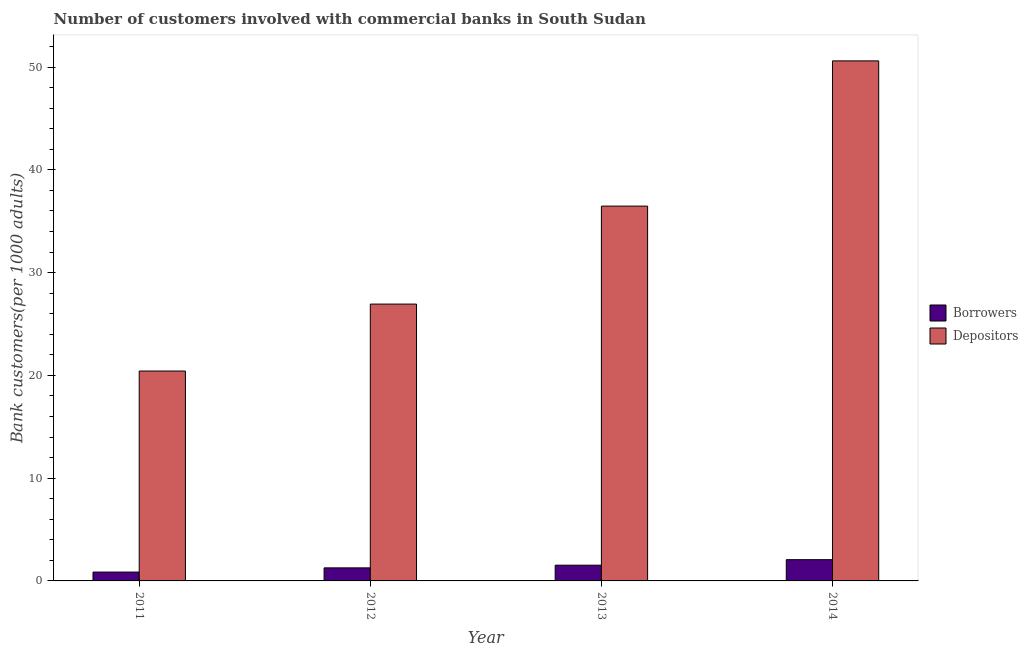How many different coloured bars are there?
Ensure brevity in your answer.  2. Are the number of bars on each tick of the X-axis equal?
Your answer should be very brief. Yes. How many bars are there on the 4th tick from the left?
Keep it short and to the point. 2. How many bars are there on the 2nd tick from the right?
Give a very brief answer. 2. What is the label of the 4th group of bars from the left?
Make the answer very short. 2014. What is the number of borrowers in 2011?
Your answer should be compact. 0.86. Across all years, what is the maximum number of depositors?
Offer a terse response. 50.61. Across all years, what is the minimum number of borrowers?
Ensure brevity in your answer.  0.86. In which year was the number of depositors maximum?
Your answer should be very brief. 2014. What is the total number of depositors in the graph?
Provide a succinct answer. 134.44. What is the difference between the number of depositors in 2011 and that in 2012?
Give a very brief answer. -6.51. What is the difference between the number of borrowers in 2011 and the number of depositors in 2012?
Offer a very short reply. -0.41. What is the average number of depositors per year?
Offer a terse response. 33.61. In how many years, is the number of depositors greater than 42?
Provide a succinct answer. 1. What is the ratio of the number of depositors in 2012 to that in 2014?
Provide a succinct answer. 0.53. Is the difference between the number of depositors in 2011 and 2014 greater than the difference between the number of borrowers in 2011 and 2014?
Ensure brevity in your answer.  No. What is the difference between the highest and the second highest number of borrowers?
Your answer should be very brief. 0.54. What is the difference between the highest and the lowest number of depositors?
Keep it short and to the point. 30.18. In how many years, is the number of borrowers greater than the average number of borrowers taken over all years?
Your answer should be compact. 2. Is the sum of the number of borrowers in 2012 and 2014 greater than the maximum number of depositors across all years?
Your answer should be very brief. Yes. What does the 2nd bar from the left in 2014 represents?
Provide a short and direct response. Depositors. What does the 2nd bar from the right in 2013 represents?
Keep it short and to the point. Borrowers. How many bars are there?
Your response must be concise. 8. How many years are there in the graph?
Provide a succinct answer. 4. Are the values on the major ticks of Y-axis written in scientific E-notation?
Your response must be concise. No. Does the graph contain any zero values?
Make the answer very short. No. Does the graph contain grids?
Your answer should be very brief. No. Where does the legend appear in the graph?
Give a very brief answer. Center right. What is the title of the graph?
Offer a terse response. Number of customers involved with commercial banks in South Sudan. What is the label or title of the X-axis?
Make the answer very short. Year. What is the label or title of the Y-axis?
Provide a short and direct response. Bank customers(per 1000 adults). What is the Bank customers(per 1000 adults) of Borrowers in 2011?
Your answer should be compact. 0.86. What is the Bank customers(per 1000 adults) in Depositors in 2011?
Your answer should be very brief. 20.42. What is the Bank customers(per 1000 adults) in Borrowers in 2012?
Keep it short and to the point. 1.27. What is the Bank customers(per 1000 adults) in Depositors in 2012?
Make the answer very short. 26.94. What is the Bank customers(per 1000 adults) of Borrowers in 2013?
Your answer should be very brief. 1.53. What is the Bank customers(per 1000 adults) of Depositors in 2013?
Provide a succinct answer. 36.47. What is the Bank customers(per 1000 adults) in Borrowers in 2014?
Your response must be concise. 2.07. What is the Bank customers(per 1000 adults) of Depositors in 2014?
Your answer should be compact. 50.61. Across all years, what is the maximum Bank customers(per 1000 adults) in Borrowers?
Offer a terse response. 2.07. Across all years, what is the maximum Bank customers(per 1000 adults) of Depositors?
Provide a succinct answer. 50.61. Across all years, what is the minimum Bank customers(per 1000 adults) of Borrowers?
Give a very brief answer. 0.86. Across all years, what is the minimum Bank customers(per 1000 adults) in Depositors?
Offer a terse response. 20.42. What is the total Bank customers(per 1000 adults) in Borrowers in the graph?
Your answer should be very brief. 5.73. What is the total Bank customers(per 1000 adults) in Depositors in the graph?
Offer a very short reply. 134.44. What is the difference between the Bank customers(per 1000 adults) in Borrowers in 2011 and that in 2012?
Ensure brevity in your answer.  -0.41. What is the difference between the Bank customers(per 1000 adults) of Depositors in 2011 and that in 2012?
Your answer should be very brief. -6.51. What is the difference between the Bank customers(per 1000 adults) of Borrowers in 2011 and that in 2013?
Provide a short and direct response. -0.67. What is the difference between the Bank customers(per 1000 adults) in Depositors in 2011 and that in 2013?
Give a very brief answer. -16.05. What is the difference between the Bank customers(per 1000 adults) of Borrowers in 2011 and that in 2014?
Offer a very short reply. -1.21. What is the difference between the Bank customers(per 1000 adults) of Depositors in 2011 and that in 2014?
Keep it short and to the point. -30.18. What is the difference between the Bank customers(per 1000 adults) of Borrowers in 2012 and that in 2013?
Your answer should be compact. -0.26. What is the difference between the Bank customers(per 1000 adults) in Depositors in 2012 and that in 2013?
Your response must be concise. -9.54. What is the difference between the Bank customers(per 1000 adults) of Borrowers in 2012 and that in 2014?
Provide a succinct answer. -0.8. What is the difference between the Bank customers(per 1000 adults) of Depositors in 2012 and that in 2014?
Give a very brief answer. -23.67. What is the difference between the Bank customers(per 1000 adults) in Borrowers in 2013 and that in 2014?
Your response must be concise. -0.54. What is the difference between the Bank customers(per 1000 adults) of Depositors in 2013 and that in 2014?
Your response must be concise. -14.13. What is the difference between the Bank customers(per 1000 adults) of Borrowers in 2011 and the Bank customers(per 1000 adults) of Depositors in 2012?
Your answer should be compact. -26.08. What is the difference between the Bank customers(per 1000 adults) in Borrowers in 2011 and the Bank customers(per 1000 adults) in Depositors in 2013?
Your response must be concise. -35.61. What is the difference between the Bank customers(per 1000 adults) in Borrowers in 2011 and the Bank customers(per 1000 adults) in Depositors in 2014?
Make the answer very short. -49.75. What is the difference between the Bank customers(per 1000 adults) in Borrowers in 2012 and the Bank customers(per 1000 adults) in Depositors in 2013?
Ensure brevity in your answer.  -35.2. What is the difference between the Bank customers(per 1000 adults) in Borrowers in 2012 and the Bank customers(per 1000 adults) in Depositors in 2014?
Offer a very short reply. -49.34. What is the difference between the Bank customers(per 1000 adults) in Borrowers in 2013 and the Bank customers(per 1000 adults) in Depositors in 2014?
Your answer should be very brief. -49.08. What is the average Bank customers(per 1000 adults) in Borrowers per year?
Offer a very short reply. 1.43. What is the average Bank customers(per 1000 adults) in Depositors per year?
Your answer should be compact. 33.61. In the year 2011, what is the difference between the Bank customers(per 1000 adults) in Borrowers and Bank customers(per 1000 adults) in Depositors?
Provide a succinct answer. -19.56. In the year 2012, what is the difference between the Bank customers(per 1000 adults) in Borrowers and Bank customers(per 1000 adults) in Depositors?
Your answer should be very brief. -25.67. In the year 2013, what is the difference between the Bank customers(per 1000 adults) of Borrowers and Bank customers(per 1000 adults) of Depositors?
Keep it short and to the point. -34.94. In the year 2014, what is the difference between the Bank customers(per 1000 adults) of Borrowers and Bank customers(per 1000 adults) of Depositors?
Provide a short and direct response. -48.54. What is the ratio of the Bank customers(per 1000 adults) of Borrowers in 2011 to that in 2012?
Give a very brief answer. 0.68. What is the ratio of the Bank customers(per 1000 adults) of Depositors in 2011 to that in 2012?
Give a very brief answer. 0.76. What is the ratio of the Bank customers(per 1000 adults) in Borrowers in 2011 to that in 2013?
Your answer should be compact. 0.56. What is the ratio of the Bank customers(per 1000 adults) in Depositors in 2011 to that in 2013?
Offer a terse response. 0.56. What is the ratio of the Bank customers(per 1000 adults) of Borrowers in 2011 to that in 2014?
Offer a very short reply. 0.42. What is the ratio of the Bank customers(per 1000 adults) in Depositors in 2011 to that in 2014?
Your answer should be very brief. 0.4. What is the ratio of the Bank customers(per 1000 adults) in Borrowers in 2012 to that in 2013?
Keep it short and to the point. 0.83. What is the ratio of the Bank customers(per 1000 adults) of Depositors in 2012 to that in 2013?
Your answer should be very brief. 0.74. What is the ratio of the Bank customers(per 1000 adults) in Borrowers in 2012 to that in 2014?
Make the answer very short. 0.61. What is the ratio of the Bank customers(per 1000 adults) of Depositors in 2012 to that in 2014?
Ensure brevity in your answer.  0.53. What is the ratio of the Bank customers(per 1000 adults) of Borrowers in 2013 to that in 2014?
Provide a succinct answer. 0.74. What is the ratio of the Bank customers(per 1000 adults) in Depositors in 2013 to that in 2014?
Give a very brief answer. 0.72. What is the difference between the highest and the second highest Bank customers(per 1000 adults) of Borrowers?
Your answer should be very brief. 0.54. What is the difference between the highest and the second highest Bank customers(per 1000 adults) in Depositors?
Your response must be concise. 14.13. What is the difference between the highest and the lowest Bank customers(per 1000 adults) in Borrowers?
Your response must be concise. 1.21. What is the difference between the highest and the lowest Bank customers(per 1000 adults) of Depositors?
Ensure brevity in your answer.  30.18. 